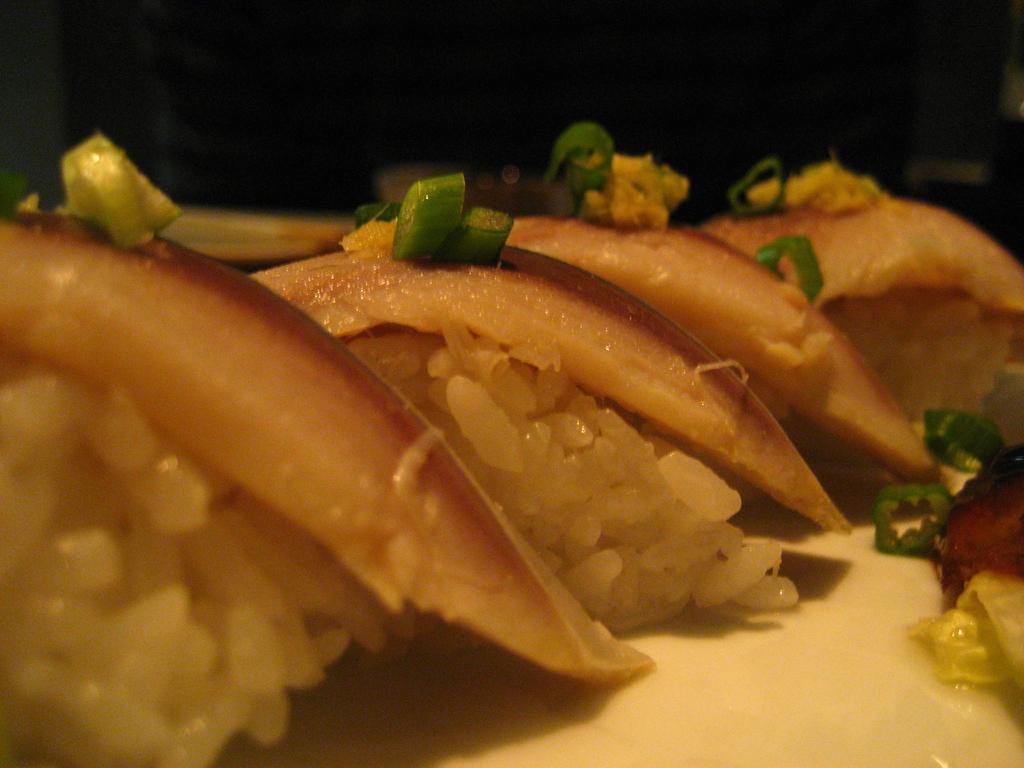Could you give a brief overview of what you see in this image? In this picture we can see food items and in the background it is dark. 